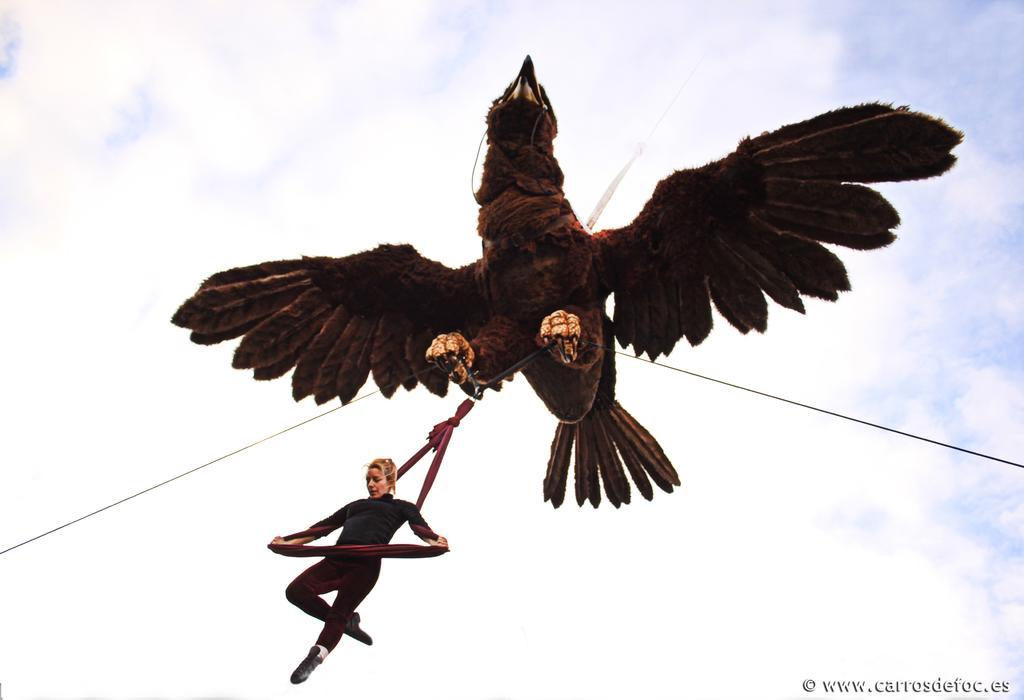In one or two sentences, can you explain what this image depicts? In this image I can see few ropes, a cloth and depiction of a brown colour bird. On the bottom side of this image I can see a woman is holding the cloth and on the bottom right side of this image I can see a watermark. In the background I can see clouds and the sky. 